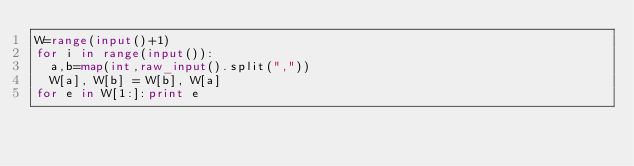<code> <loc_0><loc_0><loc_500><loc_500><_Python_>W=range(input()+1)
for i in range(input()):
  a,b=map(int,raw_input().split(","))
  W[a], W[b] = W[b], W[a]
for e in W[1:]:print e</code> 